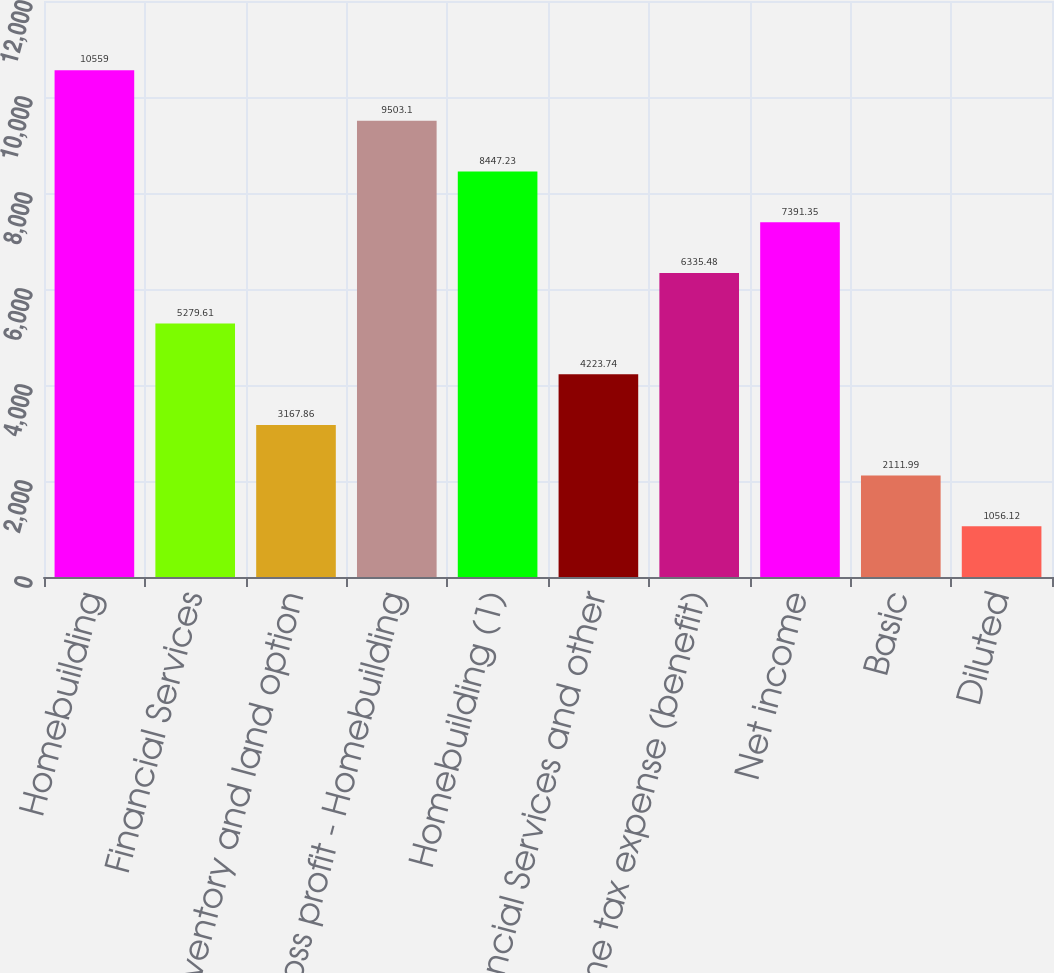Convert chart. <chart><loc_0><loc_0><loc_500><loc_500><bar_chart><fcel>Homebuilding<fcel>Financial Services<fcel>Inventory and land option<fcel>Gross profit - Homebuilding<fcel>Homebuilding (1)<fcel>Financial Services and other<fcel>Income tax expense (benefit)<fcel>Net income<fcel>Basic<fcel>Diluted<nl><fcel>10559<fcel>5279.61<fcel>3167.86<fcel>9503.1<fcel>8447.23<fcel>4223.74<fcel>6335.48<fcel>7391.35<fcel>2111.99<fcel>1056.12<nl></chart> 